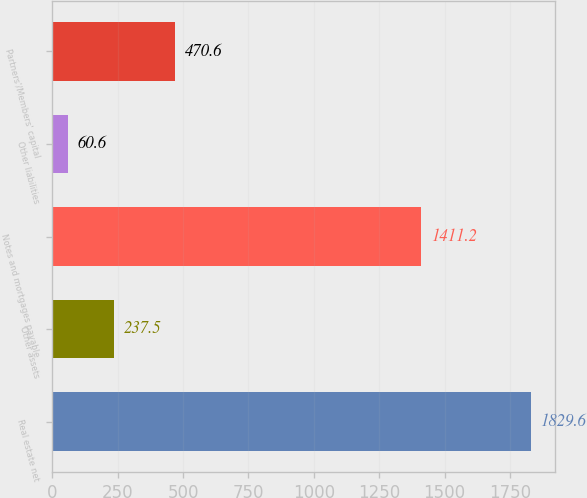<chart> <loc_0><loc_0><loc_500><loc_500><bar_chart><fcel>Real estate net<fcel>Other assets<fcel>Notes and mortgages payable<fcel>Other liabilities<fcel>Partners'/Members' capital<nl><fcel>1829.6<fcel>237.5<fcel>1411.2<fcel>60.6<fcel>470.6<nl></chart> 